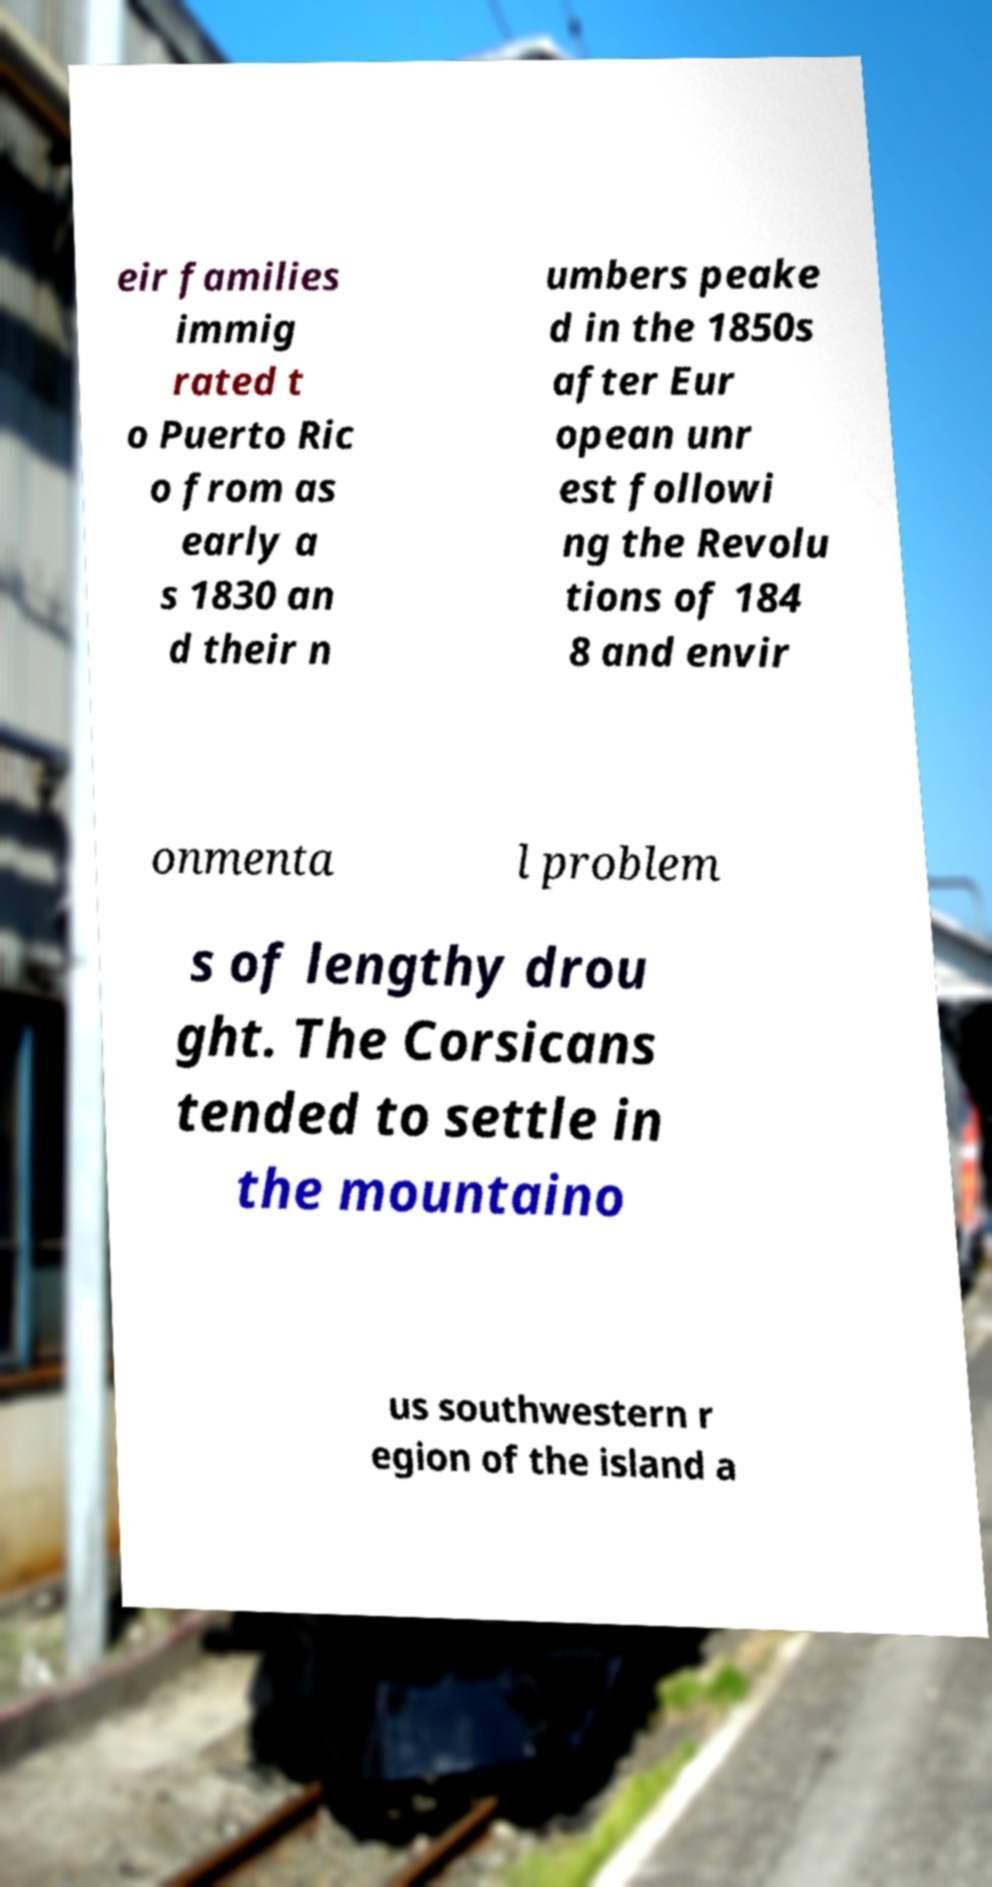For documentation purposes, I need the text within this image transcribed. Could you provide that? eir families immig rated t o Puerto Ric o from as early a s 1830 an d their n umbers peake d in the 1850s after Eur opean unr est followi ng the Revolu tions of 184 8 and envir onmenta l problem s of lengthy drou ght. The Corsicans tended to settle in the mountaino us southwestern r egion of the island a 